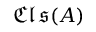Convert formula to latex. <formula><loc_0><loc_0><loc_500><loc_500>{ \mathfrak { C l s } } ( A )</formula> 